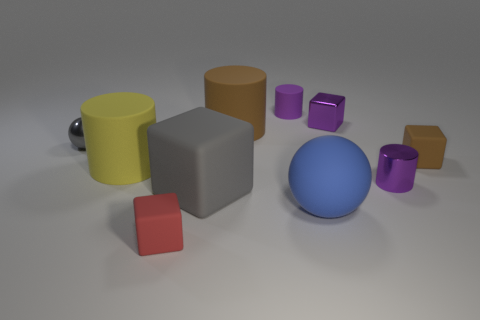Subtract all large brown rubber cylinders. How many cylinders are left? 3 Subtract all brown blocks. How many blocks are left? 3 Subtract all spheres. How many objects are left? 8 Subtract 1 spheres. How many spheres are left? 1 Subtract all red spheres. How many purple cylinders are left? 2 Subtract all blue balls. Subtract all yellow cylinders. How many balls are left? 1 Subtract all purple metal objects. Subtract all purple shiny blocks. How many objects are left? 7 Add 3 large brown things. How many large brown things are left? 4 Add 5 gray balls. How many gray balls exist? 6 Subtract 0 green cylinders. How many objects are left? 10 